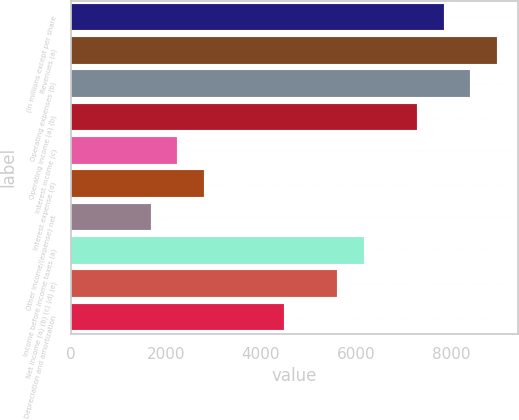Convert chart to OTSL. <chart><loc_0><loc_0><loc_500><loc_500><bar_chart><fcel>(in millions except per share<fcel>Revenues (a)<fcel>Operating expenses (b)<fcel>Operating income (a) (b)<fcel>Interest income (c)<fcel>Interest expense (d)<fcel>Other income/(expense) net<fcel>Income before income taxes (a)<fcel>Net income (a) (b) (c) (d) (e)<fcel>Depreciation and amortization<nl><fcel>7849.88<fcel>8971.22<fcel>8410.55<fcel>7289.21<fcel>2243.18<fcel>2803.85<fcel>1682.51<fcel>6167.87<fcel>5607.2<fcel>4485.86<nl></chart> 